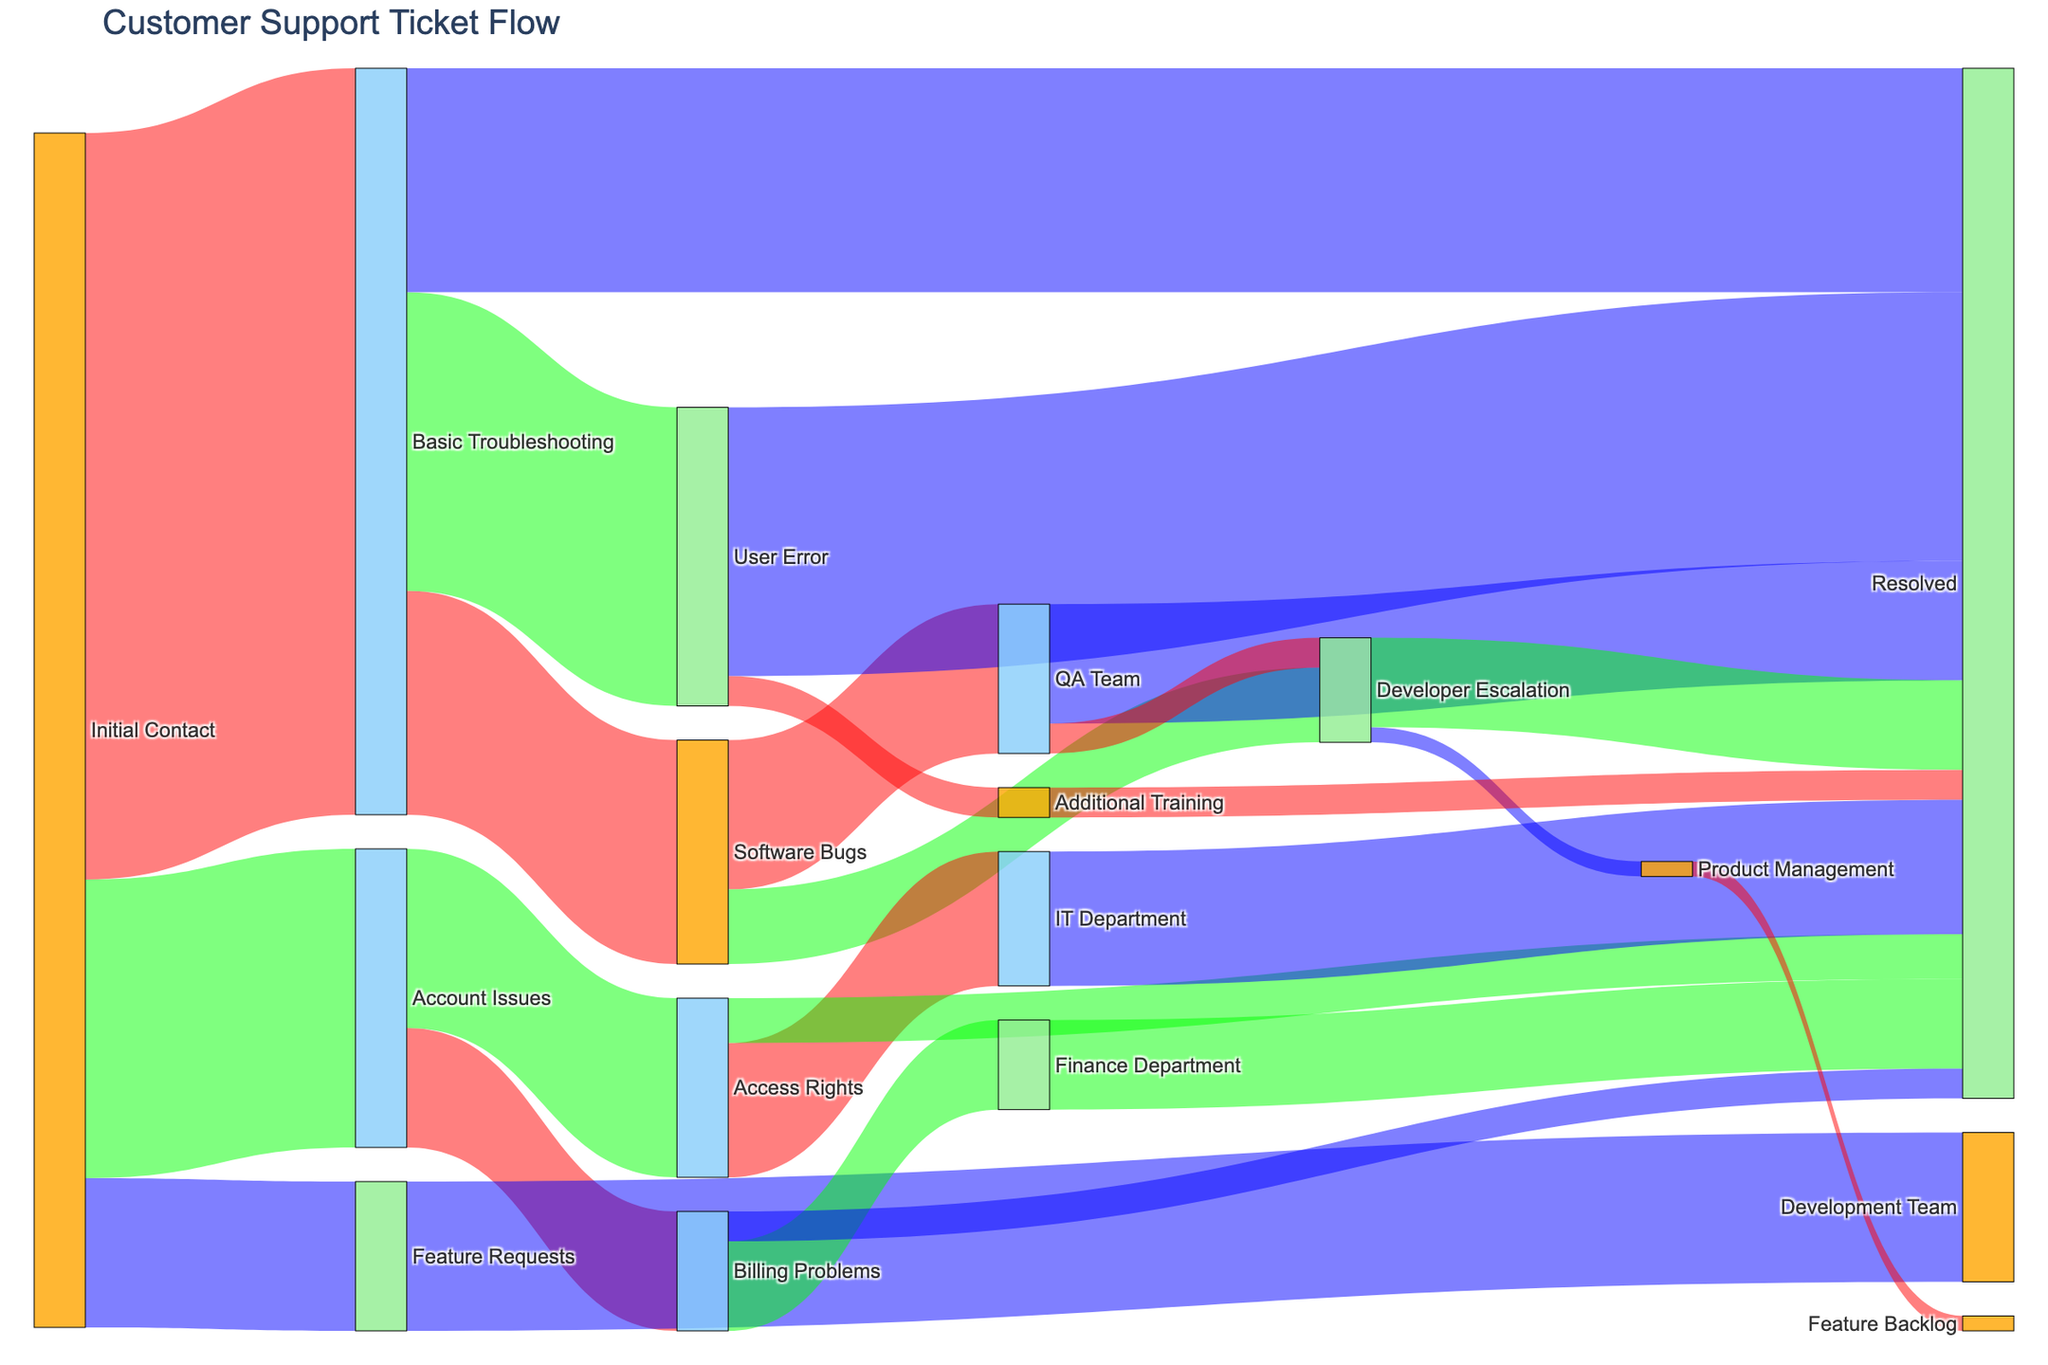What is the title of the Sankey diagram? The title of a diagram is usually located at the top of the figure and provides a brief description of the chart's content. In this case, looking at the figure should reveal "Customer Support Ticket Flow" as the title.
Answer: Customer Support Ticket Flow How many tickets proceed directly from the 'Initial Contact' stage to the 'Basic Troubleshooting' stage? The arrows (or links) between stages in a Sankey diagram indicate the flow of tickets and their quantities. According to the figure, the link from 'Initial Contact' to 'Basic Troubleshooting' indicates 500 tickets.
Answer: 500 Which stage receives the most tickets from 'Basic Troubleshooting'? By observing the width of the links (or arrows) flowing out of 'Basic Troubleshooting,' the widest link represents the greatest number of tickets. From 'Basic Troubleshooting,' most tickets flow to 'User Error' which is indicated by the link showing 200 tickets.
Answer: User Error How many tickets reach the 'Resolved' stage from 'User Error'? The ticket flow from 'User Error' to 'Resolved' is depicted in the sankey diagram. The figure should indicate a flow of 180 tickets from 'User Error' to 'Resolved'.
Answer: 180 What is the total number of tickets in the 'Account Issues' category and its subcategories? Summing up all tickets within 'Account Issues,' we add 200 (initial 'Account Issues') plus the subcategories: Billing Problems (80) and Access Rights (120). All tickets in subcategories sum to 80 + 120 = 200. So total tickets are 200 + 200 = 400.
Answer: 400 How many tickets are escalated to the 'Development Team'? The tickets from 'Feature Requests' flow to 'Development Team' as indicated by a link showing 100 tickets. Thus, the number of tickets is directly observed from the figure.
Answer: 100 Compare the total number of tickets handled by the 'QA Team' and 'IT Department.' Which one deals with more tickets? Counting the tickets handled by 'QA Team' and 'IT Department,' the 'QA Team' handles 100 tickets related to 'Software Bugs', while 'IT Department' handles 90 tickets from 'Access Rights'.
Answer: QA Team What’s the total number of tickets that get resolved without passing through any subcategories after 'Initial Contact'? The direct resolution tickets post 'Initial Contact' include flows: from 'Basic Troubleshooting' to 'Resolved' (150), from 'User Error' to 'Resolved' (180), from 'Account Issues' to 'Resolved' (20 + 30), from 'Billing Problems' to 'Resolved' (20), IT Department to 'Resolved' (90), QA Team to 'Resolved' (80), Developer Escalation to 'Resolved' (60), Additional Training to 'Resolved' (20), and Finance Department to 'Resolved' (60). Sum of all these values: 150 + 180 + 20 + 30 + 20 + 90 + 80 + 60 + 20 + 60 = 710
Answer: 710 